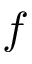<formula> <loc_0><loc_0><loc_500><loc_500>f</formula> 